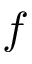<formula> <loc_0><loc_0><loc_500><loc_500>f</formula> 